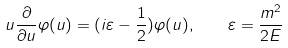<formula> <loc_0><loc_0><loc_500><loc_500>u \frac { \partial } { \partial u } \varphi ( u ) = ( i \varepsilon - \frac { 1 } { 2 } ) \varphi ( u ) , \quad \varepsilon = \frac { m ^ { 2 } } { 2 E }</formula> 